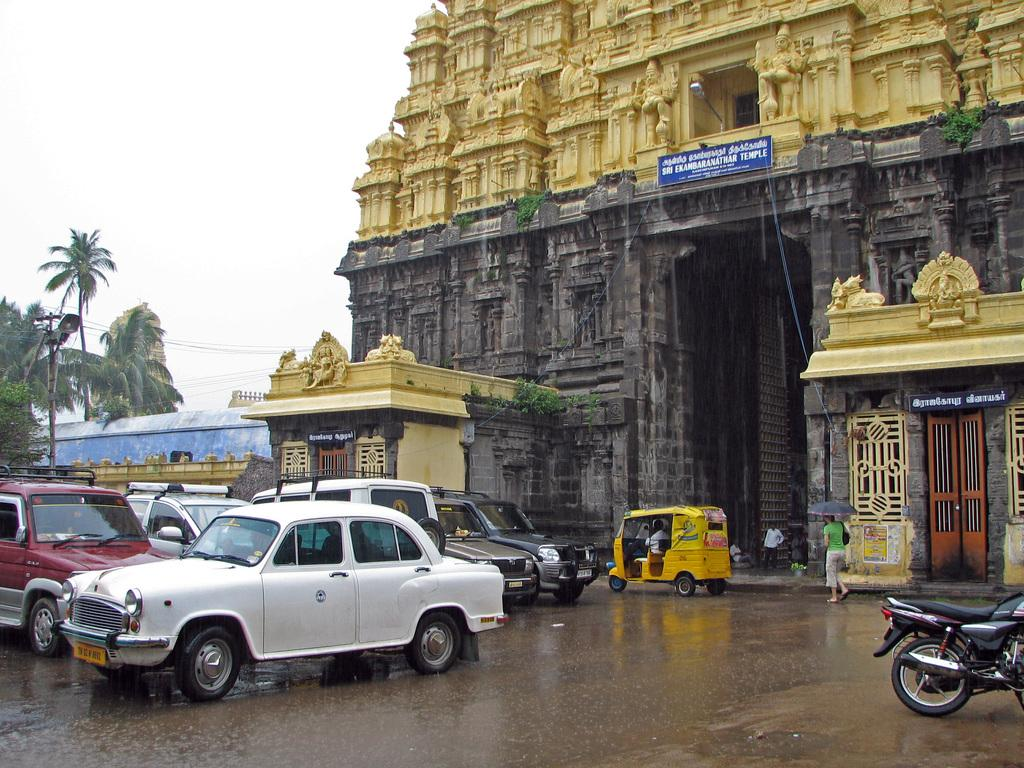What type of structure is in the image? There is a temple in the image. What can be seen in front of the temple? There are vehicles in front of the temple. What is happening in the image involving people? There are people walking in the image. What type of natural elements are visible around the temple? There are trees visible around the temple. What type of mitten is being used by the people walking in the image? There are no mittens present in the image; people are walking without any visible hand coverings. 